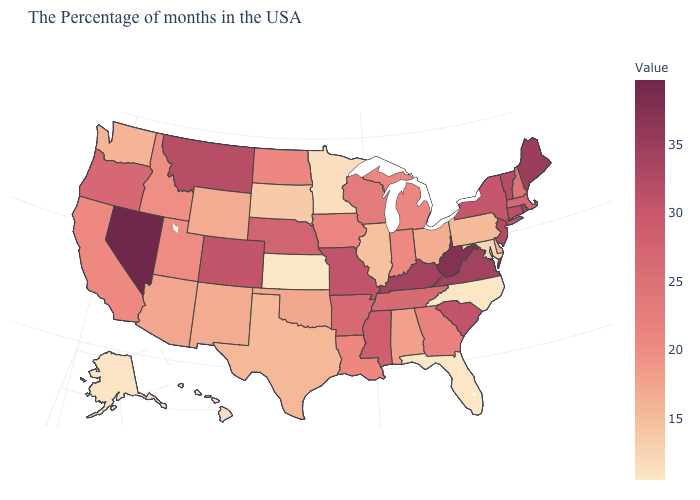Is the legend a continuous bar?
Short answer required. Yes. Does North Carolina have the lowest value in the USA?
Be succinct. Yes. Which states have the highest value in the USA?
Keep it brief. Nevada. Among the states that border Washington , which have the highest value?
Short answer required. Oregon. 